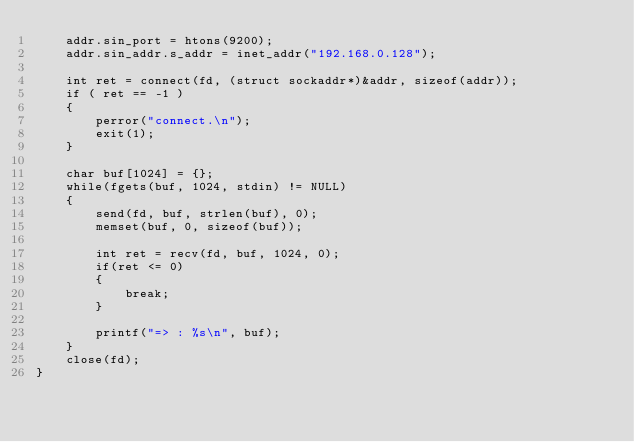Convert code to text. <code><loc_0><loc_0><loc_500><loc_500><_C_>	addr.sin_port = htons(9200);
	addr.sin_addr.s_addr = inet_addr("192.168.0.128");

	int ret = connect(fd, (struct sockaddr*)&addr, sizeof(addr));
	if ( ret == -1 )
	{
		perror("connect.\n");
		exit(1);
	}
	
	char buf[1024] = {};
	while(fgets(buf, 1024, stdin) != NULL)
	{
		send(fd, buf, strlen(buf), 0);
		memset(buf, 0, sizeof(buf));

		int ret = recv(fd, buf, 1024, 0);
		if(ret <= 0)
		{
			break;
		}

		printf("=> : %s\n", buf);
	}
	close(fd);
}


</code> 